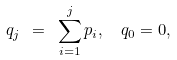Convert formula to latex. <formula><loc_0><loc_0><loc_500><loc_500>q _ { j } \ = \ \sum _ { i = 1 } ^ { j } p _ { i } , \ \ q _ { 0 } = 0 ,</formula> 